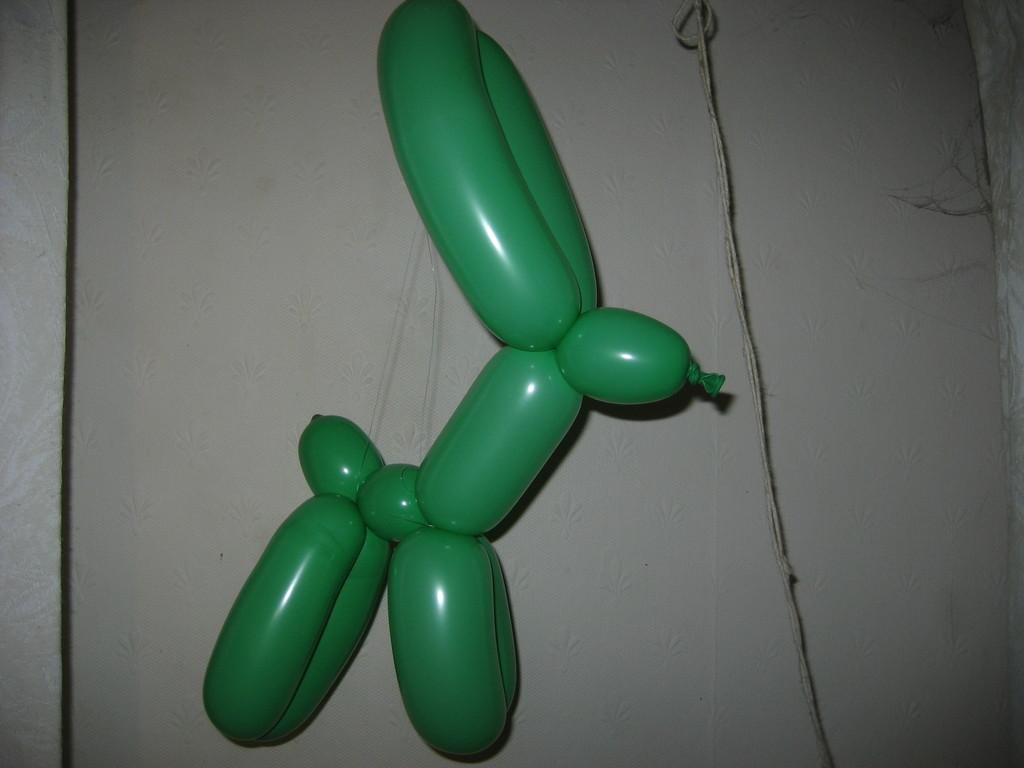Can you describe this image briefly? In this image we can see the balloons that are tied together. 